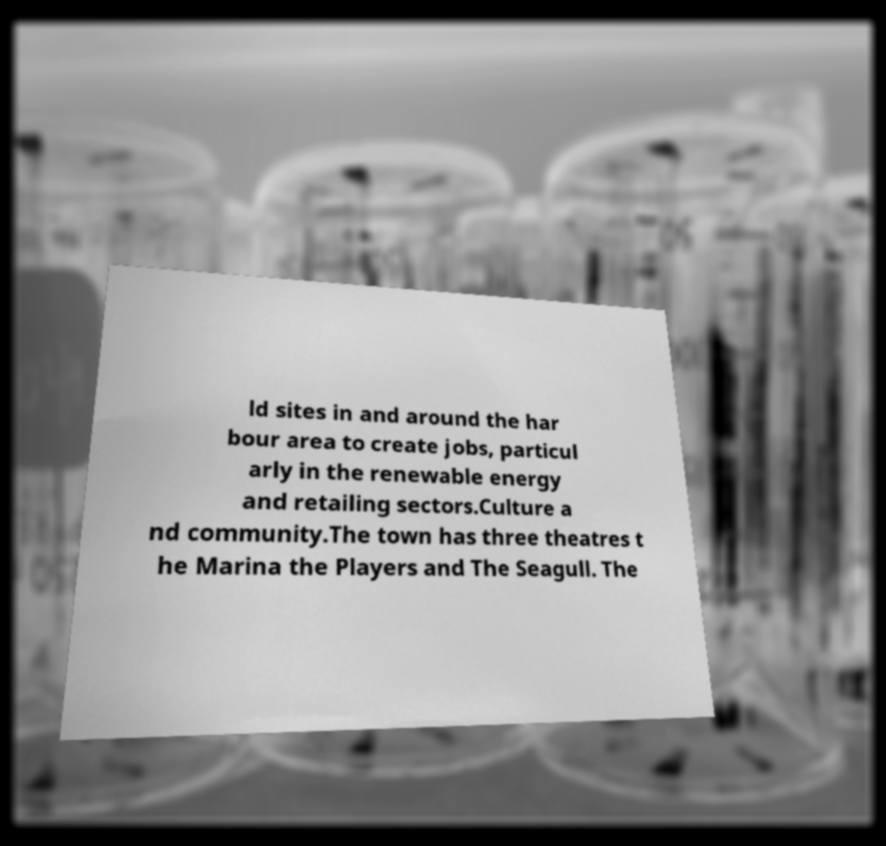I need the written content from this picture converted into text. Can you do that? ld sites in and around the har bour area to create jobs, particul arly in the renewable energy and retailing sectors.Culture a nd community.The town has three theatres t he Marina the Players and The Seagull. The 